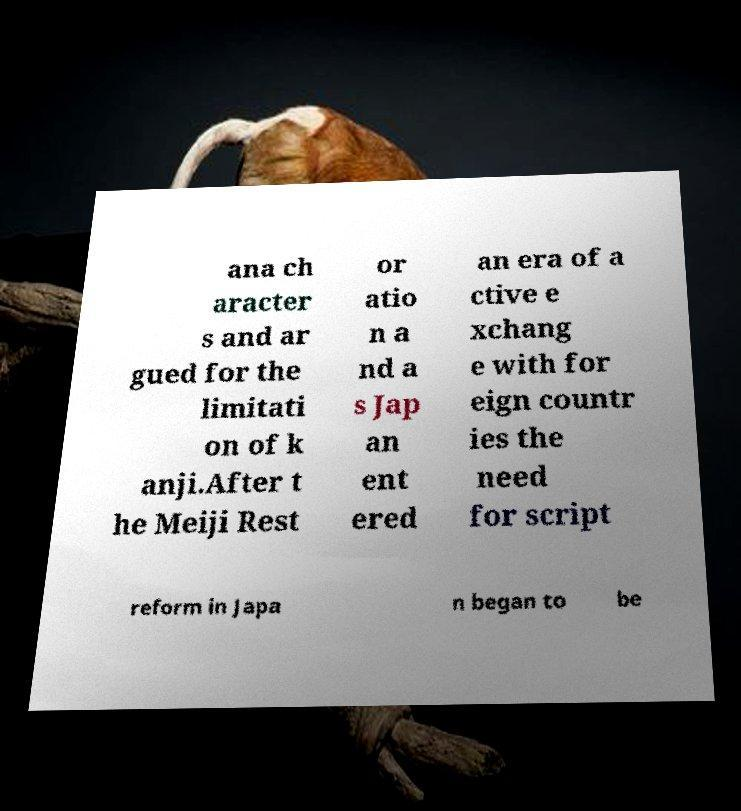Please read and relay the text visible in this image. What does it say? ana ch aracter s and ar gued for the limitati on of k anji.After t he Meiji Rest or atio n a nd a s Jap an ent ered an era of a ctive e xchang e with for eign countr ies the need for script reform in Japa n began to be 